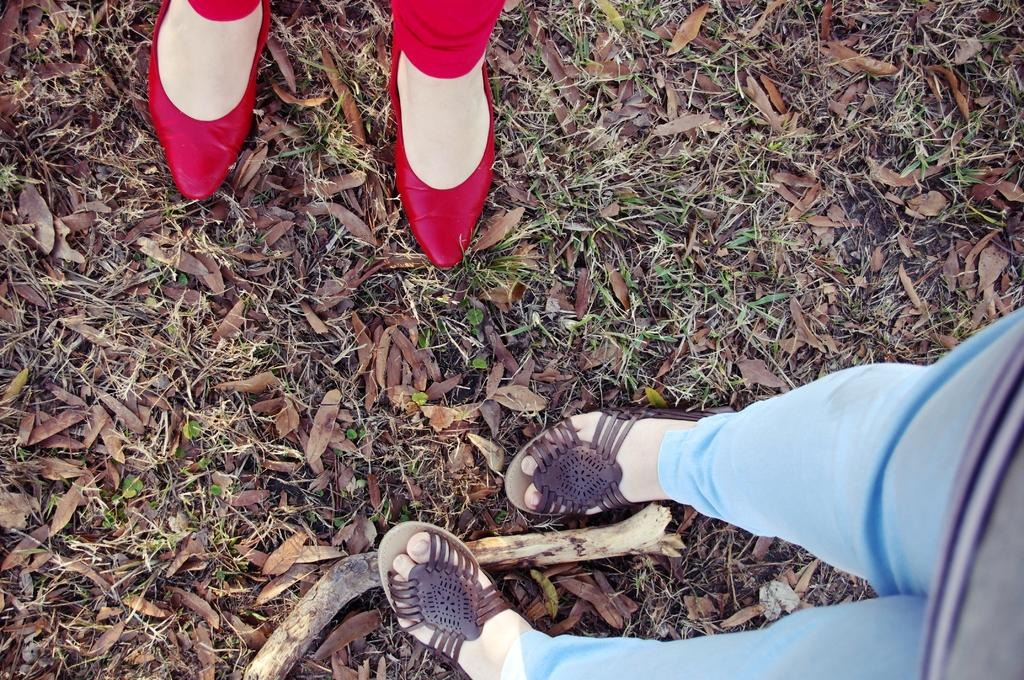What body parts can be seen in the image? There are persons' feet visible in the image. What type of vegetation is present in the image? The grass is present in the image. What type of ornament is hanging from the persons' feet in the image? There is no ornament hanging from the persons' feet in the image; only their feet and the grass are present. What type of bottle can be seen in the image? There is no bottle present in the image. 